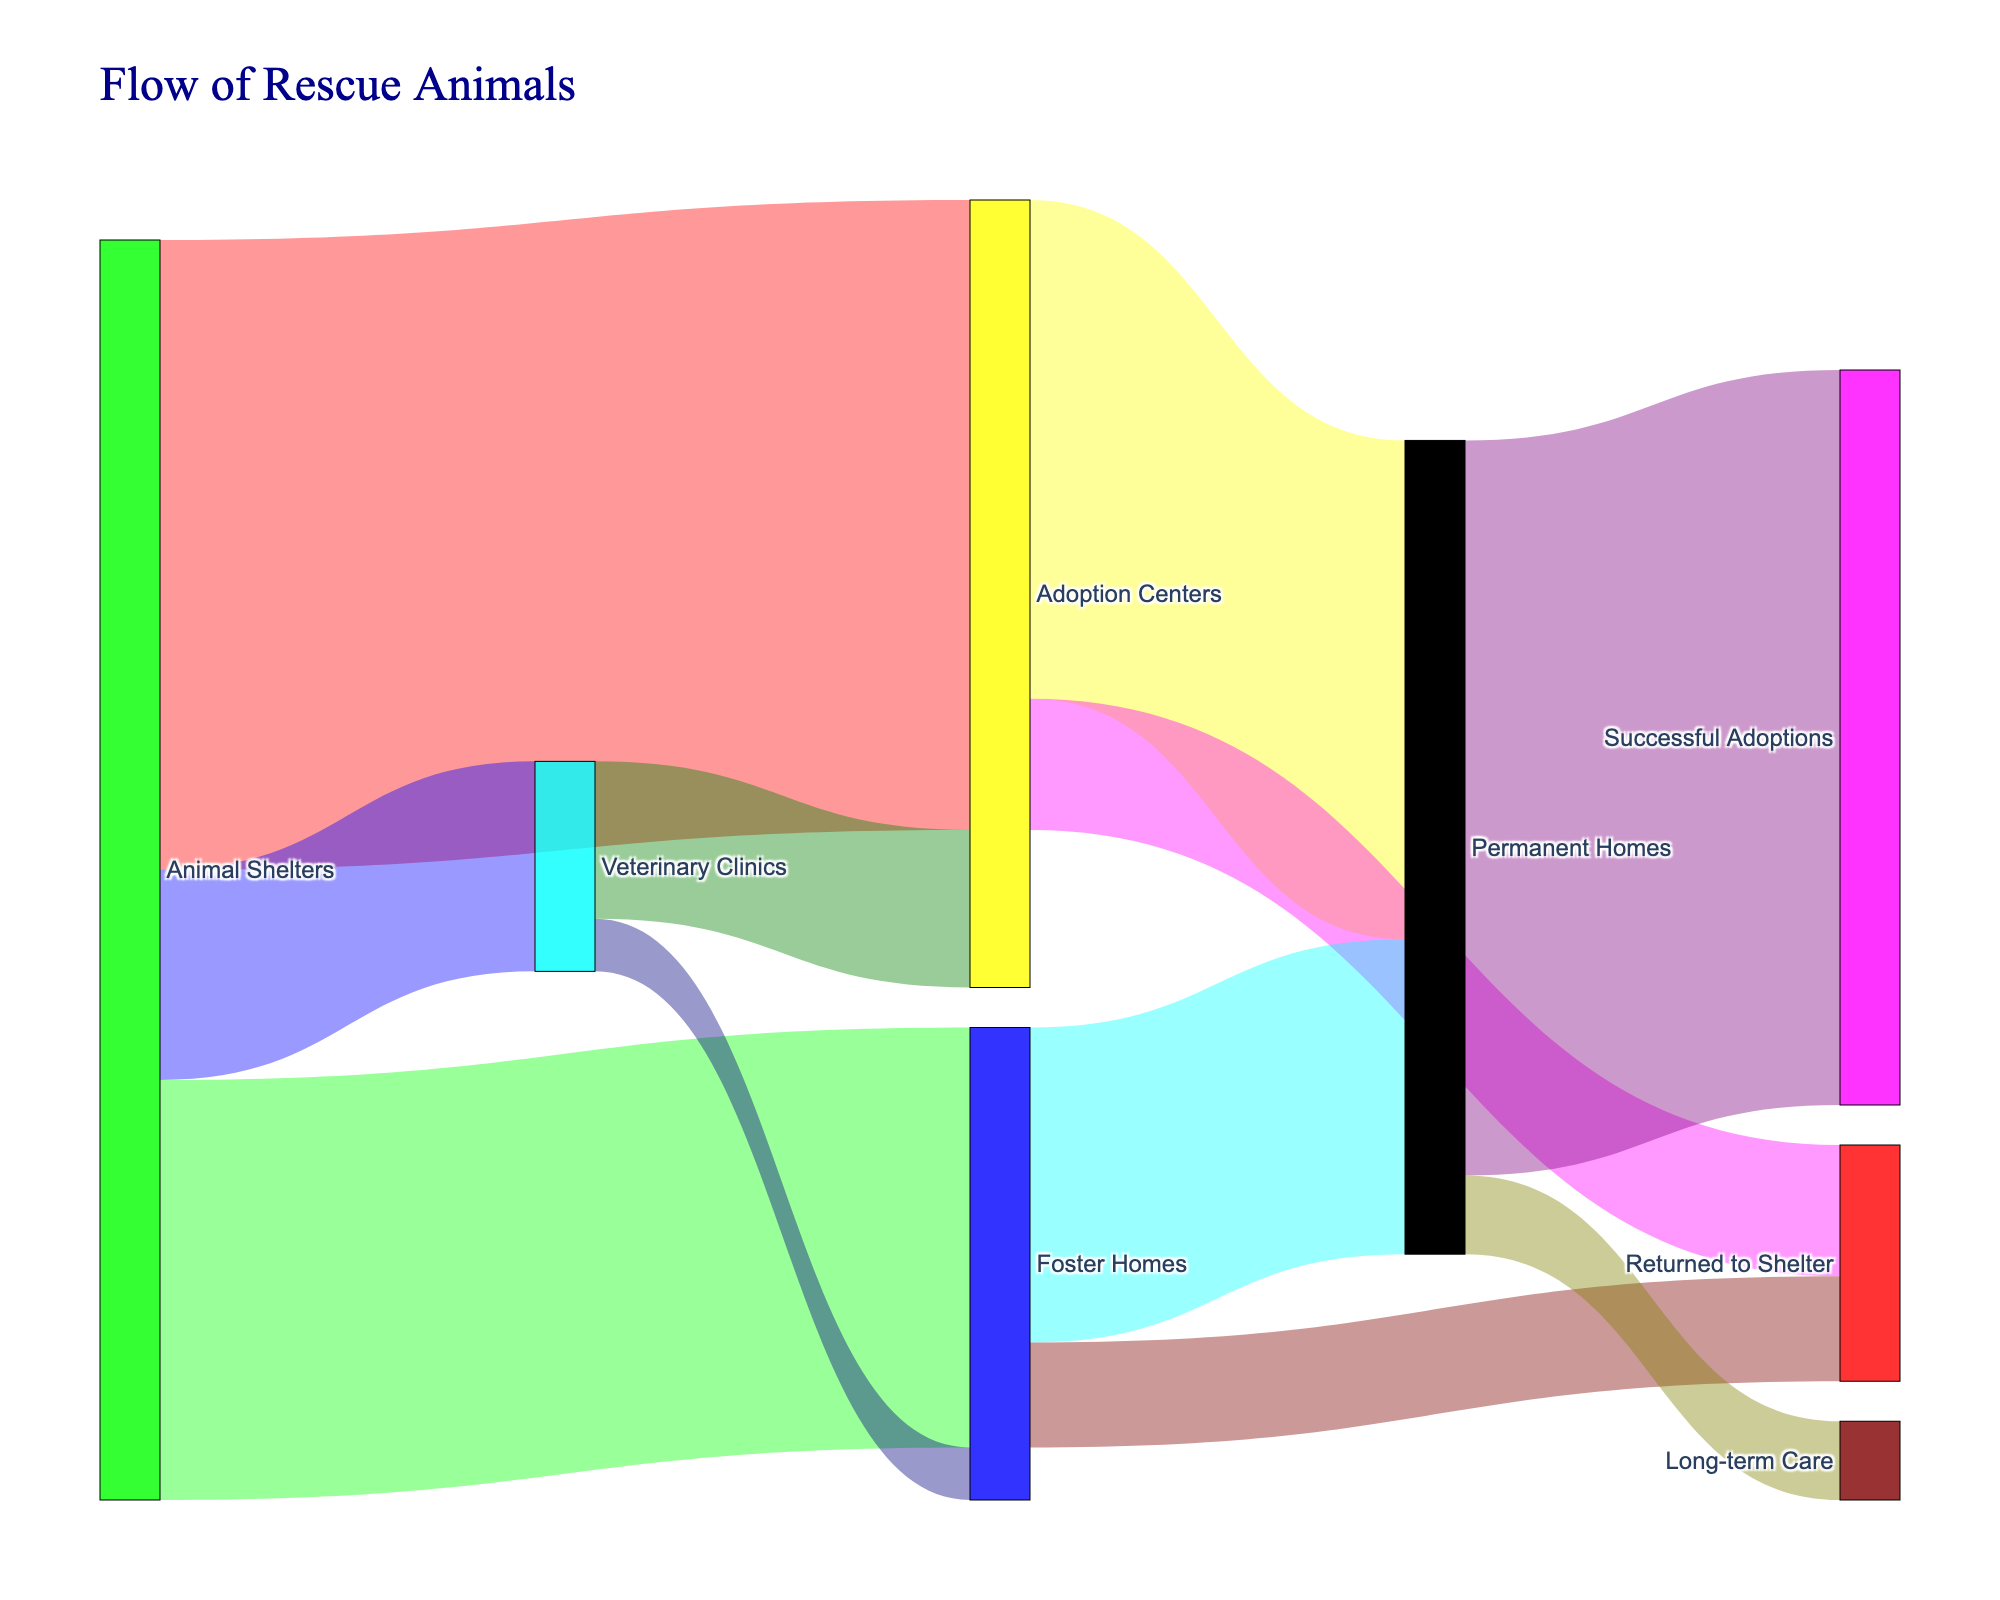How many animals were transferred from animal shelters to adoption centers? The Sankey diagram displays a flow from "Animal Shelters" to "Adoption Centers" with a numerical value. By identifying this flow, we see that 1200 animals were transferred.
Answer: 1200 How many animals went from foster homes to permanent homes? The Sankey diagram shows a connection from "Foster Homes" to "Permanent Homes" with a specific value assigned to this path. According to the diagram, 600 animals were transferred.
Answer: 600 What's the sum of animals that moved from veterinary clinics to other places? To find the sum, identify the values of all outgoing flows from "Veterinary Clinics" and add them up. The diagram shows two paths: Veterinary Clinics to Adoption Centers (300) and Veterinary Clinics to Foster Homes (100). Summing these gives 300 + 100 = 400.
Answer: 400 Which direction had more animals returning to shelters: from adoption centers or foster homes? Compare the values of the flows returning to shelters: "Adoption Centers" to "Returned to Shelter" shows 250 animals, and "Foster Homes" to "Returned to Shelter" shows 200 animals. The greater value indicates the larger flow.
Answer: Adoption Centers What is the total number of animals that ended up in permanent homes? To find this total, sum all incoming flows to "Permanent Homes." These are from "Adoption Centers" (950) and "Foster Homes" (600). Adding these gives 950 + 600 = 1550.
Answer: 1550 What percentage of animals from adoption centers were permanently adopted rather than returned to shelters? Calculate the percentage by dividing the number of animals adopted permanently by the total number of animals that left the adoption centers and multiplying by 100. From the adoption centers, 950 went to permanent homes and 250 returned to shelters. So the calculation is (950 / (950 + 250)) * 100 = (950 / 1200) * 100 = 79.17%.
Answer: 79.17% How many more animals went to fostering homes from shelters compared to those going to veterinary clinics? Subtract the number going to veterinary clinics from those going to foster homes: 800 (to Foster Homes) - 400 (to Veterinary Clinics) = 400.
Answer: 400 What's the total number of animals processed by veterinary clinics, including both incoming and outgoing? Sum all the flows involving veterinary clinics. Incoming are from shelters (400), and outgoing are to adoption centers (300) and foster homes (100). The total is 400 + 300 + 100 = 800.
Answer: 800 From which initial location did the majority of animals in permanent homes originate? Compare the incoming flows to "Permanent Homes" from different initial locations. Foster Homes contributed 600 while Adoption Centers contributed 950. The greater number indicates the majority.
Answer: Adoption Centers How many animals were successfully adopted from all sources combined? Only consider the final destination "Successful Adoptions," which receives 1400 animals as stated in the diagram.
Answer: 1400 